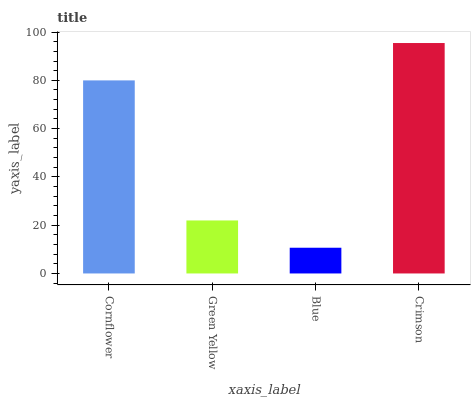Is Blue the minimum?
Answer yes or no. Yes. Is Crimson the maximum?
Answer yes or no. Yes. Is Green Yellow the minimum?
Answer yes or no. No. Is Green Yellow the maximum?
Answer yes or no. No. Is Cornflower greater than Green Yellow?
Answer yes or no. Yes. Is Green Yellow less than Cornflower?
Answer yes or no. Yes. Is Green Yellow greater than Cornflower?
Answer yes or no. No. Is Cornflower less than Green Yellow?
Answer yes or no. No. Is Cornflower the high median?
Answer yes or no. Yes. Is Green Yellow the low median?
Answer yes or no. Yes. Is Green Yellow the high median?
Answer yes or no. No. Is Blue the low median?
Answer yes or no. No. 